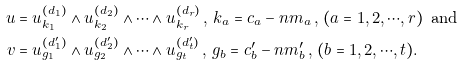<formula> <loc_0><loc_0><loc_500><loc_500>u & = u _ { k _ { 1 } } ^ { ( d _ { 1 } ) } \wedge u _ { k _ { 2 } } ^ { ( d _ { 2 } ) } \wedge \cdots \wedge u _ { k _ { r } } ^ { ( d _ { r } ) } \, , \, k _ { a } = c _ { a } - n m _ { a } \, , \, ( a = 1 , 2 , \cdots , r ) \, \text { and } \\ v & = u _ { g _ { 1 } } ^ { ( d _ { 1 } ^ { \prime } ) } \wedge u _ { g _ { 2 } } ^ { ( d _ { 2 } ^ { \prime } ) } \wedge \cdots \wedge u _ { g _ { t } } ^ { ( d _ { t } ^ { \prime } ) } \, , \, g _ { b } = c _ { b } ^ { \prime } - n m _ { b } ^ { \prime } \, , \, ( b = 1 , 2 , \cdots , t ) .</formula> 